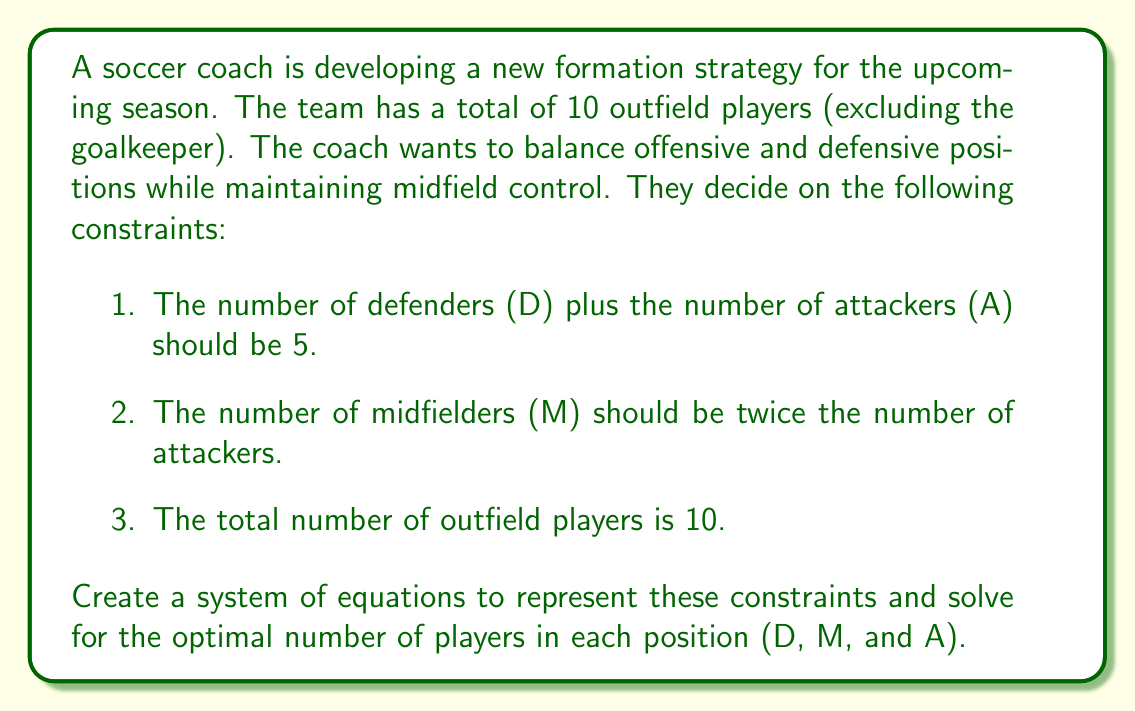Help me with this question. Let's approach this step-by-step:

1) First, we'll translate the given constraints into mathematical equations:

   a) $D + A = 5$
   b) $M = 2A$
   c) $D + M + A = 10$

2) Now we have a system of three equations with three unknowns. Let's solve it:

3) From equation (a), we can express D in terms of A:
   $D = 5 - A$

4) Substitute this into equation (c):
   $(5 - A) + M + A = 10$
   $5 + M = 10$
   $M = 5$

5) Now, using equation (b):
   $5 = 2A$
   $A = \frac{5}{2} = 2.5$

6) However, since we can't have fractional players, we need to round to the nearest whole number:
   $A = 3$

7) Now we can find D using equation (a):
   $D = 5 - A = 5 - 3 = 2$

8) Let's verify using equation (c):
   $D + M + A = 2 + 5 + 3 = 10$

Therefore, the optimal number of players for each position is:
Defenders (D) = 2
Midfielders (M) = 5
Attackers (A) = 3
Answer: D = 2, M = 5, A = 3 